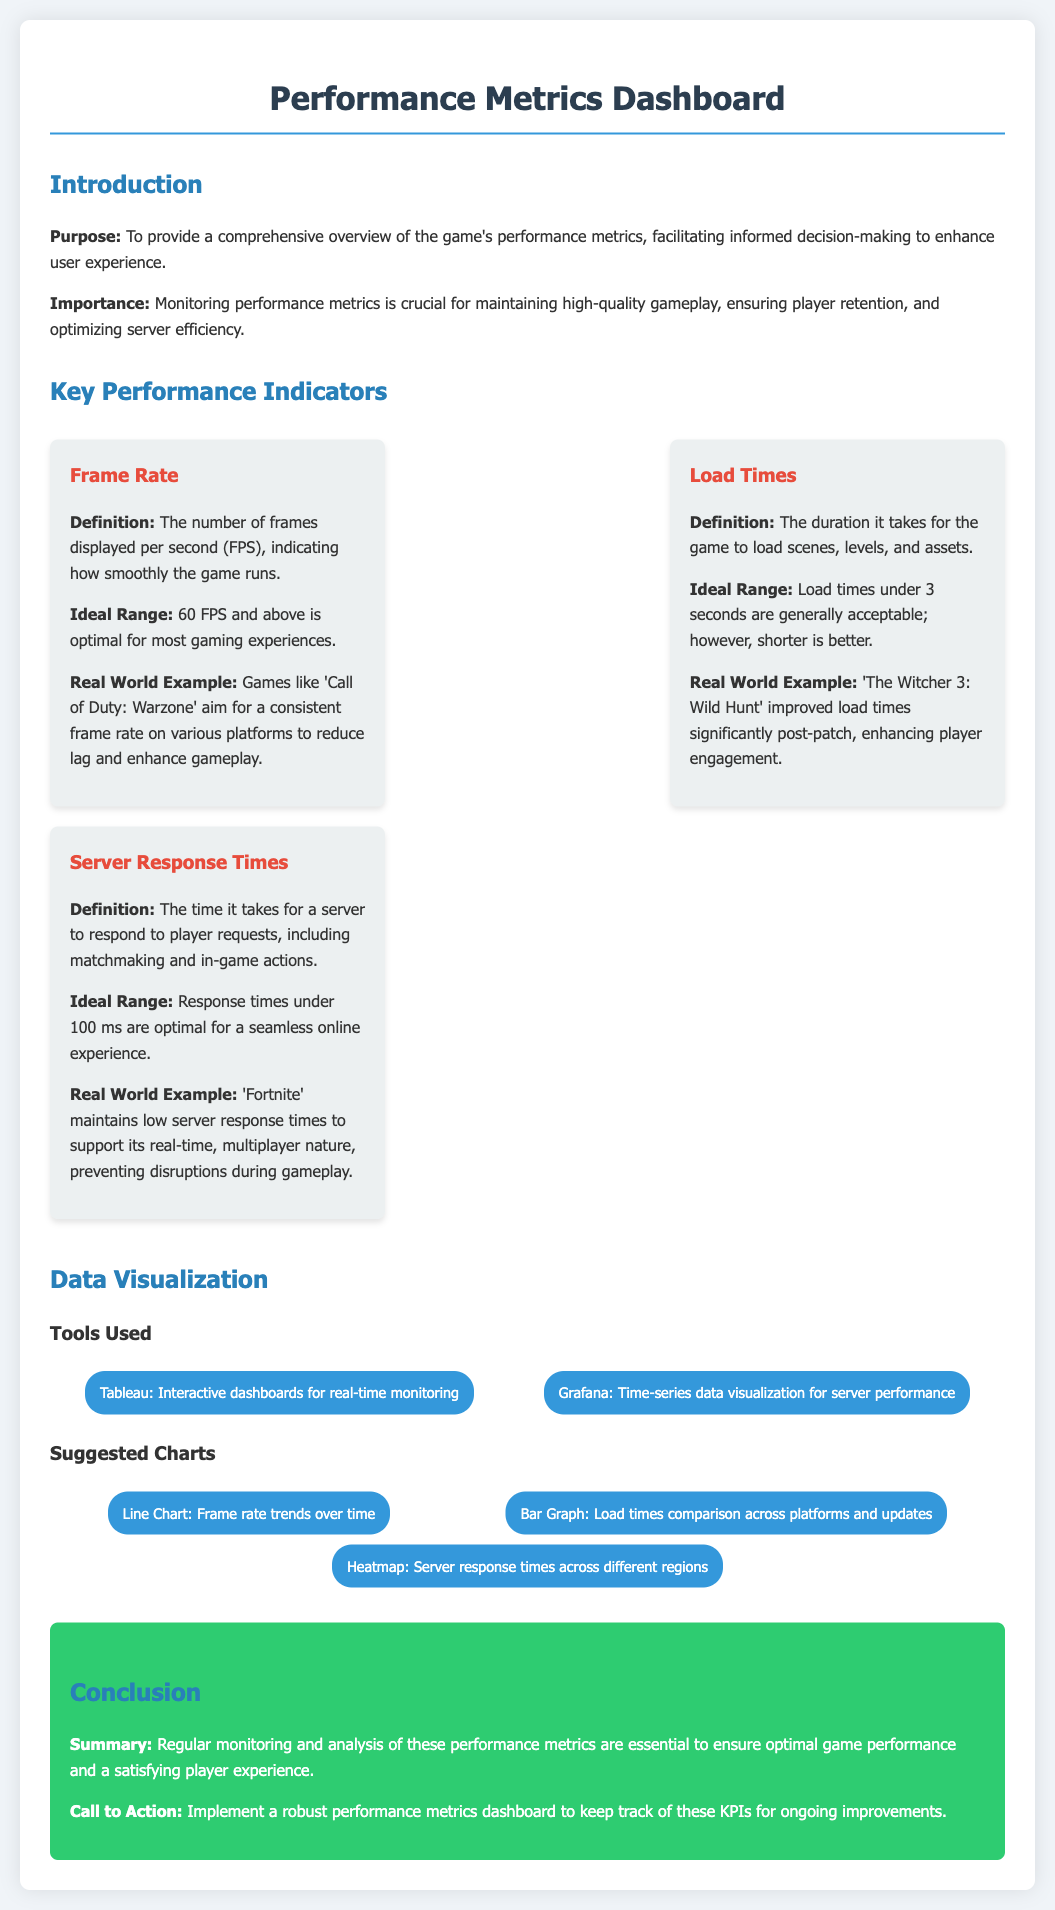What is the purpose of the dashboard? The purpose of the dashboard is to provide a comprehensive overview of the game's performance metrics, facilitating informed decision-making to enhance user experience.
Answer: Comprehensive overview of the game's performance metrics What is the ideal frame rate for optimal gaming experiences? The ideal frame rate for optimal gaming experiences is mentioned as 60 FPS and above.
Answer: 60 FPS What load time is generally acceptable? The acceptable load time mentioned is under 3 seconds, although shorter is better.
Answer: Under 3 seconds What is the optimal server response time? The optimal server response time stated is under 100 ms for a seamless online experience.
Answer: Under 100 ms Which game is cited as having improved load times significantly? 'The Witcher 3: Wild Hunt' is cited as having improved load times significantly post-patch.
Answer: The Witcher 3: Wild Hunt What type of chart is suggested for visualizing frame rate trends? A line chart is suggested for visualizing frame rate trends over time.
Answer: Line Chart What tools are mentioned for data visualization? The tools mentioned for data visualization are Tableau and Grafana.
Answer: Tableau and Grafana What is the call to action in the conclusion? The call to action is to implement a robust performance metrics dashboard to keep track of these KPIs for ongoing improvements.
Answer: Implement a robust performance metrics dashboard 